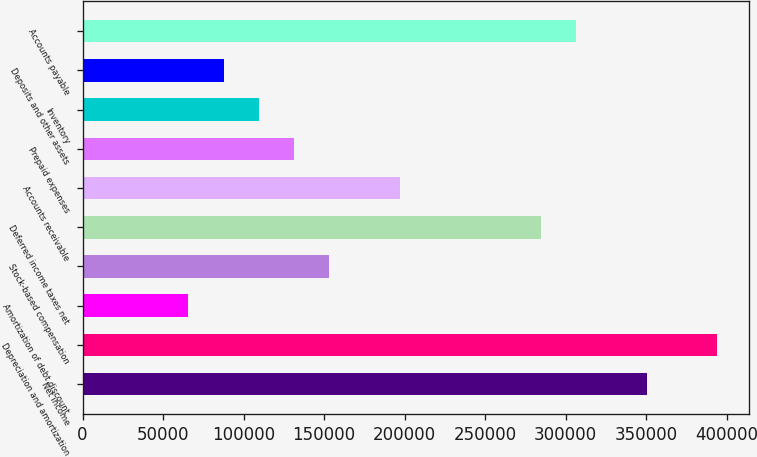Convert chart. <chart><loc_0><loc_0><loc_500><loc_500><bar_chart><fcel>Net income<fcel>Depreciation and amortization<fcel>Amortization of debt discount<fcel>Stock-based compensation<fcel>Deferred income taxes net<fcel>Accounts receivable<fcel>Prepaid expenses<fcel>Inventory<fcel>Deposits and other assets<fcel>Accounts payable<nl><fcel>350479<fcel>394288<fcel>65716.4<fcel>153336<fcel>284764<fcel>197145<fcel>131431<fcel>109526<fcel>87621.2<fcel>306669<nl></chart> 